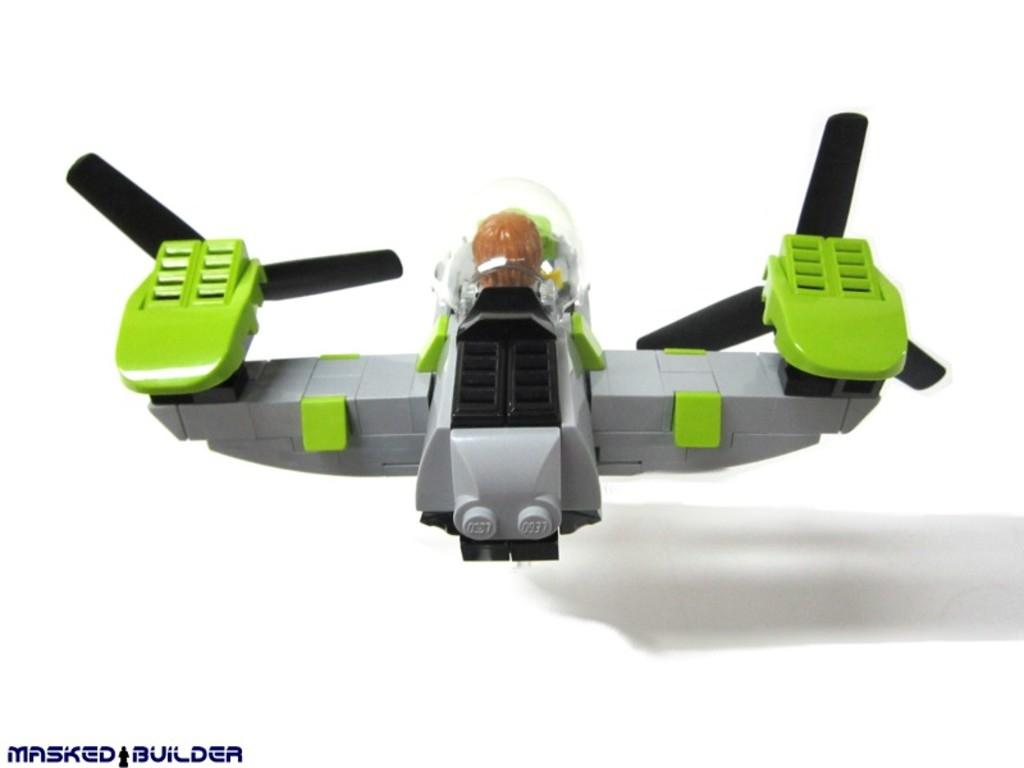What is the main subject of the image? There is an object that looks like a toy in the image. Is there any text present in the image? Yes, there is text in the bottom left corner of the image. What color is the background of the image? The background of the image is white. What type of wood is used to make the badge in the image? There is no badge present in the image, and therefore no wood can be associated with it. 